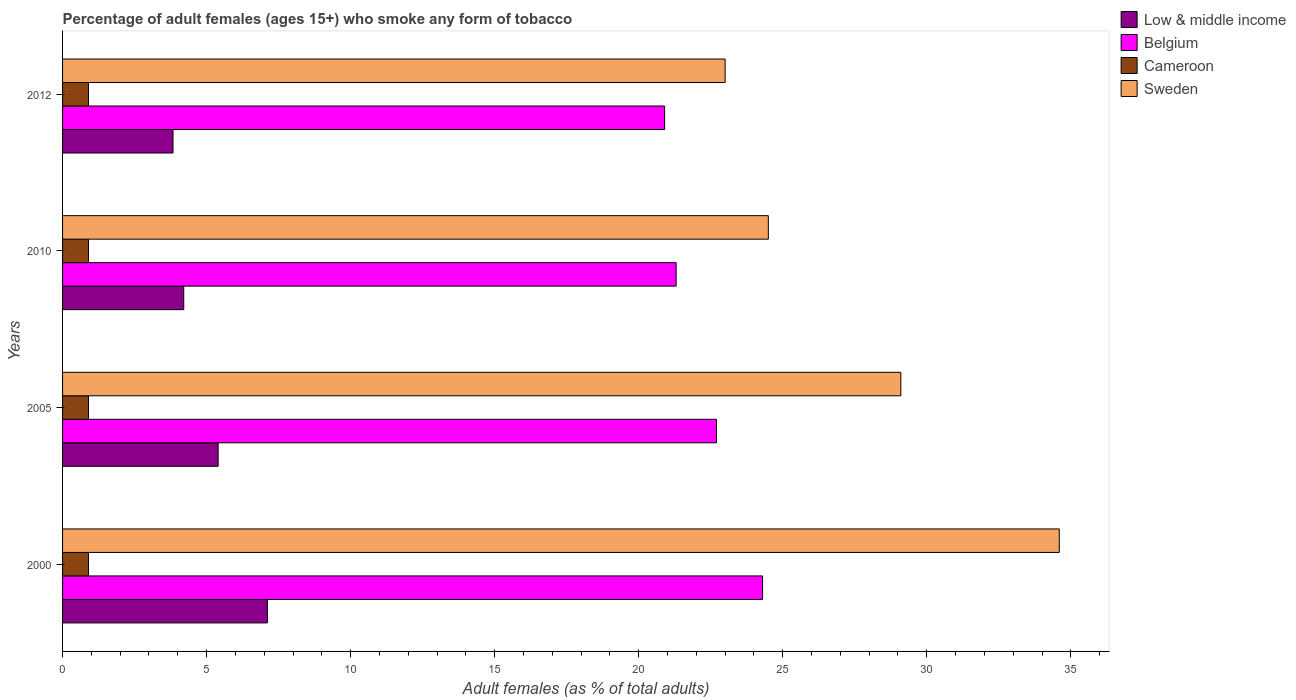How many groups of bars are there?
Offer a very short reply. 4. Are the number of bars per tick equal to the number of legend labels?
Offer a very short reply. Yes. Are the number of bars on each tick of the Y-axis equal?
Keep it short and to the point. Yes. How many bars are there on the 1st tick from the bottom?
Provide a short and direct response. 4. What is the percentage of adult females who smoke in Low & middle income in 2005?
Make the answer very short. 5.4. Across all years, what is the maximum percentage of adult females who smoke in Low & middle income?
Your answer should be very brief. 7.11. Across all years, what is the minimum percentage of adult females who smoke in Low & middle income?
Your answer should be very brief. 3.83. In which year was the percentage of adult females who smoke in Cameroon maximum?
Make the answer very short. 2000. What is the total percentage of adult females who smoke in Sweden in the graph?
Ensure brevity in your answer.  111.2. What is the difference between the percentage of adult females who smoke in Sweden in 2005 and the percentage of adult females who smoke in Cameroon in 2000?
Keep it short and to the point. 28.2. What is the average percentage of adult females who smoke in Belgium per year?
Give a very brief answer. 22.3. In the year 2005, what is the difference between the percentage of adult females who smoke in Sweden and percentage of adult females who smoke in Cameroon?
Ensure brevity in your answer.  28.2. In how many years, is the percentage of adult females who smoke in Sweden greater than 27 %?
Give a very brief answer. 2. What is the ratio of the percentage of adult females who smoke in Low & middle income in 2005 to that in 2010?
Your answer should be very brief. 1.28. What is the difference between the highest and the lowest percentage of adult females who smoke in Cameroon?
Offer a terse response. 0. In how many years, is the percentage of adult females who smoke in Belgium greater than the average percentage of adult females who smoke in Belgium taken over all years?
Your response must be concise. 2. Is it the case that in every year, the sum of the percentage of adult females who smoke in Low & middle income and percentage of adult females who smoke in Sweden is greater than the sum of percentage of adult females who smoke in Belgium and percentage of adult females who smoke in Cameroon?
Provide a succinct answer. Yes. How many bars are there?
Make the answer very short. 16. Are all the bars in the graph horizontal?
Your answer should be compact. Yes. How many years are there in the graph?
Offer a terse response. 4. What is the difference between two consecutive major ticks on the X-axis?
Your answer should be very brief. 5. Are the values on the major ticks of X-axis written in scientific E-notation?
Offer a terse response. No. Does the graph contain grids?
Make the answer very short. No. How are the legend labels stacked?
Provide a short and direct response. Vertical. What is the title of the graph?
Your response must be concise. Percentage of adult females (ages 15+) who smoke any form of tobacco. Does "Tunisia" appear as one of the legend labels in the graph?
Make the answer very short. No. What is the label or title of the X-axis?
Offer a very short reply. Adult females (as % of total adults). What is the Adult females (as % of total adults) in Low & middle income in 2000?
Make the answer very short. 7.11. What is the Adult females (as % of total adults) in Belgium in 2000?
Your response must be concise. 24.3. What is the Adult females (as % of total adults) of Sweden in 2000?
Your answer should be very brief. 34.6. What is the Adult females (as % of total adults) in Low & middle income in 2005?
Ensure brevity in your answer.  5.4. What is the Adult females (as % of total adults) of Belgium in 2005?
Make the answer very short. 22.7. What is the Adult females (as % of total adults) of Cameroon in 2005?
Make the answer very short. 0.9. What is the Adult females (as % of total adults) in Sweden in 2005?
Your answer should be compact. 29.1. What is the Adult females (as % of total adults) in Low & middle income in 2010?
Ensure brevity in your answer.  4.21. What is the Adult females (as % of total adults) of Belgium in 2010?
Give a very brief answer. 21.3. What is the Adult females (as % of total adults) in Low & middle income in 2012?
Your response must be concise. 3.83. What is the Adult females (as % of total adults) of Belgium in 2012?
Offer a terse response. 20.9. What is the Adult females (as % of total adults) of Cameroon in 2012?
Make the answer very short. 0.9. Across all years, what is the maximum Adult females (as % of total adults) of Low & middle income?
Offer a terse response. 7.11. Across all years, what is the maximum Adult females (as % of total adults) of Belgium?
Keep it short and to the point. 24.3. Across all years, what is the maximum Adult females (as % of total adults) in Sweden?
Provide a short and direct response. 34.6. Across all years, what is the minimum Adult females (as % of total adults) of Low & middle income?
Make the answer very short. 3.83. Across all years, what is the minimum Adult females (as % of total adults) of Belgium?
Keep it short and to the point. 20.9. Across all years, what is the minimum Adult females (as % of total adults) in Sweden?
Your response must be concise. 23. What is the total Adult females (as % of total adults) of Low & middle income in the graph?
Make the answer very short. 20.55. What is the total Adult females (as % of total adults) in Belgium in the graph?
Your answer should be compact. 89.2. What is the total Adult females (as % of total adults) in Sweden in the graph?
Provide a succinct answer. 111.2. What is the difference between the Adult females (as % of total adults) in Low & middle income in 2000 and that in 2005?
Make the answer very short. 1.71. What is the difference between the Adult females (as % of total adults) of Belgium in 2000 and that in 2005?
Keep it short and to the point. 1.6. What is the difference between the Adult females (as % of total adults) of Cameroon in 2000 and that in 2005?
Your answer should be compact. 0. What is the difference between the Adult females (as % of total adults) in Sweden in 2000 and that in 2005?
Your answer should be very brief. 5.5. What is the difference between the Adult females (as % of total adults) in Low & middle income in 2000 and that in 2010?
Provide a succinct answer. 2.9. What is the difference between the Adult females (as % of total adults) in Sweden in 2000 and that in 2010?
Offer a terse response. 10.1. What is the difference between the Adult females (as % of total adults) in Low & middle income in 2000 and that in 2012?
Make the answer very short. 3.28. What is the difference between the Adult females (as % of total adults) in Belgium in 2000 and that in 2012?
Provide a short and direct response. 3.4. What is the difference between the Adult females (as % of total adults) of Low & middle income in 2005 and that in 2010?
Provide a succinct answer. 1.19. What is the difference between the Adult females (as % of total adults) in Cameroon in 2005 and that in 2010?
Provide a short and direct response. 0. What is the difference between the Adult females (as % of total adults) in Sweden in 2005 and that in 2010?
Keep it short and to the point. 4.6. What is the difference between the Adult females (as % of total adults) in Low & middle income in 2005 and that in 2012?
Give a very brief answer. 1.57. What is the difference between the Adult females (as % of total adults) of Cameroon in 2005 and that in 2012?
Your response must be concise. 0. What is the difference between the Adult females (as % of total adults) of Sweden in 2005 and that in 2012?
Your answer should be compact. 6.1. What is the difference between the Adult females (as % of total adults) in Low & middle income in 2010 and that in 2012?
Offer a terse response. 0.37. What is the difference between the Adult females (as % of total adults) of Cameroon in 2010 and that in 2012?
Your response must be concise. 0. What is the difference between the Adult females (as % of total adults) in Sweden in 2010 and that in 2012?
Your answer should be very brief. 1.5. What is the difference between the Adult females (as % of total adults) of Low & middle income in 2000 and the Adult females (as % of total adults) of Belgium in 2005?
Ensure brevity in your answer.  -15.59. What is the difference between the Adult females (as % of total adults) in Low & middle income in 2000 and the Adult females (as % of total adults) in Cameroon in 2005?
Offer a very short reply. 6.21. What is the difference between the Adult females (as % of total adults) in Low & middle income in 2000 and the Adult females (as % of total adults) in Sweden in 2005?
Keep it short and to the point. -21.99. What is the difference between the Adult females (as % of total adults) of Belgium in 2000 and the Adult females (as % of total adults) of Cameroon in 2005?
Your response must be concise. 23.4. What is the difference between the Adult females (as % of total adults) of Belgium in 2000 and the Adult females (as % of total adults) of Sweden in 2005?
Ensure brevity in your answer.  -4.8. What is the difference between the Adult females (as % of total adults) in Cameroon in 2000 and the Adult females (as % of total adults) in Sweden in 2005?
Keep it short and to the point. -28.2. What is the difference between the Adult females (as % of total adults) of Low & middle income in 2000 and the Adult females (as % of total adults) of Belgium in 2010?
Your answer should be very brief. -14.19. What is the difference between the Adult females (as % of total adults) in Low & middle income in 2000 and the Adult females (as % of total adults) in Cameroon in 2010?
Keep it short and to the point. 6.21. What is the difference between the Adult females (as % of total adults) in Low & middle income in 2000 and the Adult females (as % of total adults) in Sweden in 2010?
Your answer should be very brief. -17.39. What is the difference between the Adult females (as % of total adults) of Belgium in 2000 and the Adult females (as % of total adults) of Cameroon in 2010?
Your response must be concise. 23.4. What is the difference between the Adult females (as % of total adults) in Belgium in 2000 and the Adult females (as % of total adults) in Sweden in 2010?
Your answer should be very brief. -0.2. What is the difference between the Adult females (as % of total adults) in Cameroon in 2000 and the Adult females (as % of total adults) in Sweden in 2010?
Make the answer very short. -23.6. What is the difference between the Adult females (as % of total adults) of Low & middle income in 2000 and the Adult females (as % of total adults) of Belgium in 2012?
Your answer should be compact. -13.79. What is the difference between the Adult females (as % of total adults) in Low & middle income in 2000 and the Adult females (as % of total adults) in Cameroon in 2012?
Provide a succinct answer. 6.21. What is the difference between the Adult females (as % of total adults) of Low & middle income in 2000 and the Adult females (as % of total adults) of Sweden in 2012?
Your answer should be compact. -15.89. What is the difference between the Adult females (as % of total adults) of Belgium in 2000 and the Adult females (as % of total adults) of Cameroon in 2012?
Your response must be concise. 23.4. What is the difference between the Adult females (as % of total adults) in Belgium in 2000 and the Adult females (as % of total adults) in Sweden in 2012?
Provide a short and direct response. 1.3. What is the difference between the Adult females (as % of total adults) of Cameroon in 2000 and the Adult females (as % of total adults) of Sweden in 2012?
Offer a very short reply. -22.1. What is the difference between the Adult females (as % of total adults) in Low & middle income in 2005 and the Adult females (as % of total adults) in Belgium in 2010?
Provide a short and direct response. -15.9. What is the difference between the Adult females (as % of total adults) in Low & middle income in 2005 and the Adult females (as % of total adults) in Cameroon in 2010?
Your answer should be compact. 4.5. What is the difference between the Adult females (as % of total adults) in Low & middle income in 2005 and the Adult females (as % of total adults) in Sweden in 2010?
Offer a terse response. -19.1. What is the difference between the Adult females (as % of total adults) of Belgium in 2005 and the Adult females (as % of total adults) of Cameroon in 2010?
Offer a very short reply. 21.8. What is the difference between the Adult females (as % of total adults) in Belgium in 2005 and the Adult females (as % of total adults) in Sweden in 2010?
Your answer should be compact. -1.8. What is the difference between the Adult females (as % of total adults) of Cameroon in 2005 and the Adult females (as % of total adults) of Sweden in 2010?
Offer a very short reply. -23.6. What is the difference between the Adult females (as % of total adults) of Low & middle income in 2005 and the Adult females (as % of total adults) of Belgium in 2012?
Your response must be concise. -15.5. What is the difference between the Adult females (as % of total adults) of Low & middle income in 2005 and the Adult females (as % of total adults) of Cameroon in 2012?
Provide a short and direct response. 4.5. What is the difference between the Adult females (as % of total adults) in Low & middle income in 2005 and the Adult females (as % of total adults) in Sweden in 2012?
Your answer should be compact. -17.6. What is the difference between the Adult females (as % of total adults) in Belgium in 2005 and the Adult females (as % of total adults) in Cameroon in 2012?
Ensure brevity in your answer.  21.8. What is the difference between the Adult females (as % of total adults) in Cameroon in 2005 and the Adult females (as % of total adults) in Sweden in 2012?
Ensure brevity in your answer.  -22.1. What is the difference between the Adult females (as % of total adults) of Low & middle income in 2010 and the Adult females (as % of total adults) of Belgium in 2012?
Offer a very short reply. -16.69. What is the difference between the Adult females (as % of total adults) of Low & middle income in 2010 and the Adult females (as % of total adults) of Cameroon in 2012?
Your answer should be compact. 3.31. What is the difference between the Adult females (as % of total adults) in Low & middle income in 2010 and the Adult females (as % of total adults) in Sweden in 2012?
Offer a very short reply. -18.79. What is the difference between the Adult females (as % of total adults) of Belgium in 2010 and the Adult females (as % of total adults) of Cameroon in 2012?
Provide a short and direct response. 20.4. What is the difference between the Adult females (as % of total adults) in Belgium in 2010 and the Adult females (as % of total adults) in Sweden in 2012?
Your answer should be very brief. -1.7. What is the difference between the Adult females (as % of total adults) of Cameroon in 2010 and the Adult females (as % of total adults) of Sweden in 2012?
Your answer should be compact. -22.1. What is the average Adult females (as % of total adults) of Low & middle income per year?
Keep it short and to the point. 5.14. What is the average Adult females (as % of total adults) of Belgium per year?
Keep it short and to the point. 22.3. What is the average Adult females (as % of total adults) in Cameroon per year?
Make the answer very short. 0.9. What is the average Adult females (as % of total adults) in Sweden per year?
Make the answer very short. 27.8. In the year 2000, what is the difference between the Adult females (as % of total adults) of Low & middle income and Adult females (as % of total adults) of Belgium?
Offer a very short reply. -17.19. In the year 2000, what is the difference between the Adult females (as % of total adults) in Low & middle income and Adult females (as % of total adults) in Cameroon?
Provide a succinct answer. 6.21. In the year 2000, what is the difference between the Adult females (as % of total adults) of Low & middle income and Adult females (as % of total adults) of Sweden?
Provide a succinct answer. -27.49. In the year 2000, what is the difference between the Adult females (as % of total adults) of Belgium and Adult females (as % of total adults) of Cameroon?
Offer a very short reply. 23.4. In the year 2000, what is the difference between the Adult females (as % of total adults) in Belgium and Adult females (as % of total adults) in Sweden?
Make the answer very short. -10.3. In the year 2000, what is the difference between the Adult females (as % of total adults) of Cameroon and Adult females (as % of total adults) of Sweden?
Keep it short and to the point. -33.7. In the year 2005, what is the difference between the Adult females (as % of total adults) in Low & middle income and Adult females (as % of total adults) in Belgium?
Provide a succinct answer. -17.3. In the year 2005, what is the difference between the Adult females (as % of total adults) in Low & middle income and Adult females (as % of total adults) in Cameroon?
Your response must be concise. 4.5. In the year 2005, what is the difference between the Adult females (as % of total adults) of Low & middle income and Adult females (as % of total adults) of Sweden?
Make the answer very short. -23.7. In the year 2005, what is the difference between the Adult females (as % of total adults) in Belgium and Adult females (as % of total adults) in Cameroon?
Make the answer very short. 21.8. In the year 2005, what is the difference between the Adult females (as % of total adults) of Belgium and Adult females (as % of total adults) of Sweden?
Give a very brief answer. -6.4. In the year 2005, what is the difference between the Adult females (as % of total adults) of Cameroon and Adult females (as % of total adults) of Sweden?
Your answer should be compact. -28.2. In the year 2010, what is the difference between the Adult females (as % of total adults) of Low & middle income and Adult females (as % of total adults) of Belgium?
Your answer should be compact. -17.09. In the year 2010, what is the difference between the Adult females (as % of total adults) of Low & middle income and Adult females (as % of total adults) of Cameroon?
Make the answer very short. 3.31. In the year 2010, what is the difference between the Adult females (as % of total adults) in Low & middle income and Adult females (as % of total adults) in Sweden?
Offer a very short reply. -20.29. In the year 2010, what is the difference between the Adult females (as % of total adults) in Belgium and Adult females (as % of total adults) in Cameroon?
Offer a terse response. 20.4. In the year 2010, what is the difference between the Adult females (as % of total adults) in Cameroon and Adult females (as % of total adults) in Sweden?
Provide a short and direct response. -23.6. In the year 2012, what is the difference between the Adult females (as % of total adults) in Low & middle income and Adult females (as % of total adults) in Belgium?
Your response must be concise. -17.07. In the year 2012, what is the difference between the Adult females (as % of total adults) in Low & middle income and Adult females (as % of total adults) in Cameroon?
Provide a succinct answer. 2.93. In the year 2012, what is the difference between the Adult females (as % of total adults) in Low & middle income and Adult females (as % of total adults) in Sweden?
Provide a succinct answer. -19.17. In the year 2012, what is the difference between the Adult females (as % of total adults) in Cameroon and Adult females (as % of total adults) in Sweden?
Make the answer very short. -22.1. What is the ratio of the Adult females (as % of total adults) of Low & middle income in 2000 to that in 2005?
Offer a terse response. 1.32. What is the ratio of the Adult females (as % of total adults) in Belgium in 2000 to that in 2005?
Your answer should be very brief. 1.07. What is the ratio of the Adult females (as % of total adults) of Cameroon in 2000 to that in 2005?
Provide a short and direct response. 1. What is the ratio of the Adult females (as % of total adults) in Sweden in 2000 to that in 2005?
Offer a terse response. 1.19. What is the ratio of the Adult females (as % of total adults) of Low & middle income in 2000 to that in 2010?
Offer a very short reply. 1.69. What is the ratio of the Adult females (as % of total adults) in Belgium in 2000 to that in 2010?
Ensure brevity in your answer.  1.14. What is the ratio of the Adult females (as % of total adults) in Sweden in 2000 to that in 2010?
Keep it short and to the point. 1.41. What is the ratio of the Adult females (as % of total adults) of Low & middle income in 2000 to that in 2012?
Provide a short and direct response. 1.85. What is the ratio of the Adult females (as % of total adults) of Belgium in 2000 to that in 2012?
Keep it short and to the point. 1.16. What is the ratio of the Adult females (as % of total adults) in Sweden in 2000 to that in 2012?
Give a very brief answer. 1.5. What is the ratio of the Adult females (as % of total adults) of Low & middle income in 2005 to that in 2010?
Offer a terse response. 1.28. What is the ratio of the Adult females (as % of total adults) in Belgium in 2005 to that in 2010?
Make the answer very short. 1.07. What is the ratio of the Adult females (as % of total adults) of Cameroon in 2005 to that in 2010?
Your answer should be compact. 1. What is the ratio of the Adult females (as % of total adults) in Sweden in 2005 to that in 2010?
Offer a terse response. 1.19. What is the ratio of the Adult females (as % of total adults) of Low & middle income in 2005 to that in 2012?
Provide a short and direct response. 1.41. What is the ratio of the Adult females (as % of total adults) of Belgium in 2005 to that in 2012?
Make the answer very short. 1.09. What is the ratio of the Adult females (as % of total adults) in Cameroon in 2005 to that in 2012?
Make the answer very short. 1. What is the ratio of the Adult females (as % of total adults) in Sweden in 2005 to that in 2012?
Provide a succinct answer. 1.27. What is the ratio of the Adult females (as % of total adults) in Low & middle income in 2010 to that in 2012?
Your answer should be very brief. 1.1. What is the ratio of the Adult females (as % of total adults) in Belgium in 2010 to that in 2012?
Offer a terse response. 1.02. What is the ratio of the Adult females (as % of total adults) of Cameroon in 2010 to that in 2012?
Keep it short and to the point. 1. What is the ratio of the Adult females (as % of total adults) in Sweden in 2010 to that in 2012?
Keep it short and to the point. 1.07. What is the difference between the highest and the second highest Adult females (as % of total adults) of Low & middle income?
Keep it short and to the point. 1.71. What is the difference between the highest and the second highest Adult females (as % of total adults) in Belgium?
Offer a terse response. 1.6. What is the difference between the highest and the second highest Adult females (as % of total adults) of Cameroon?
Give a very brief answer. 0. What is the difference between the highest and the second highest Adult females (as % of total adults) in Sweden?
Offer a terse response. 5.5. What is the difference between the highest and the lowest Adult females (as % of total adults) of Low & middle income?
Your response must be concise. 3.28. What is the difference between the highest and the lowest Adult females (as % of total adults) in Belgium?
Ensure brevity in your answer.  3.4. What is the difference between the highest and the lowest Adult females (as % of total adults) in Cameroon?
Keep it short and to the point. 0. 